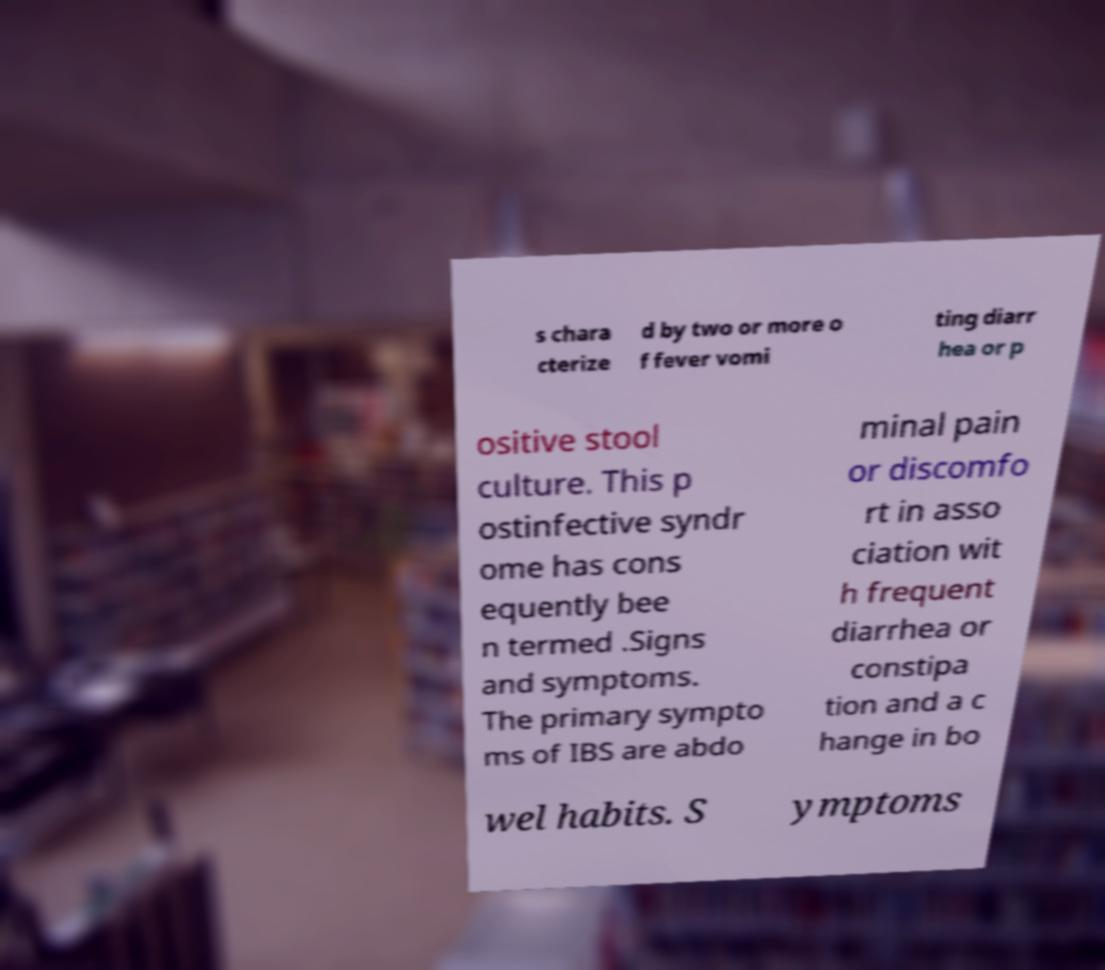Can you accurately transcribe the text from the provided image for me? s chara cterize d by two or more o f fever vomi ting diarr hea or p ositive stool culture. This p ostinfective syndr ome has cons equently bee n termed .Signs and symptoms. The primary sympto ms of IBS are abdo minal pain or discomfo rt in asso ciation wit h frequent diarrhea or constipa tion and a c hange in bo wel habits. S ymptoms 